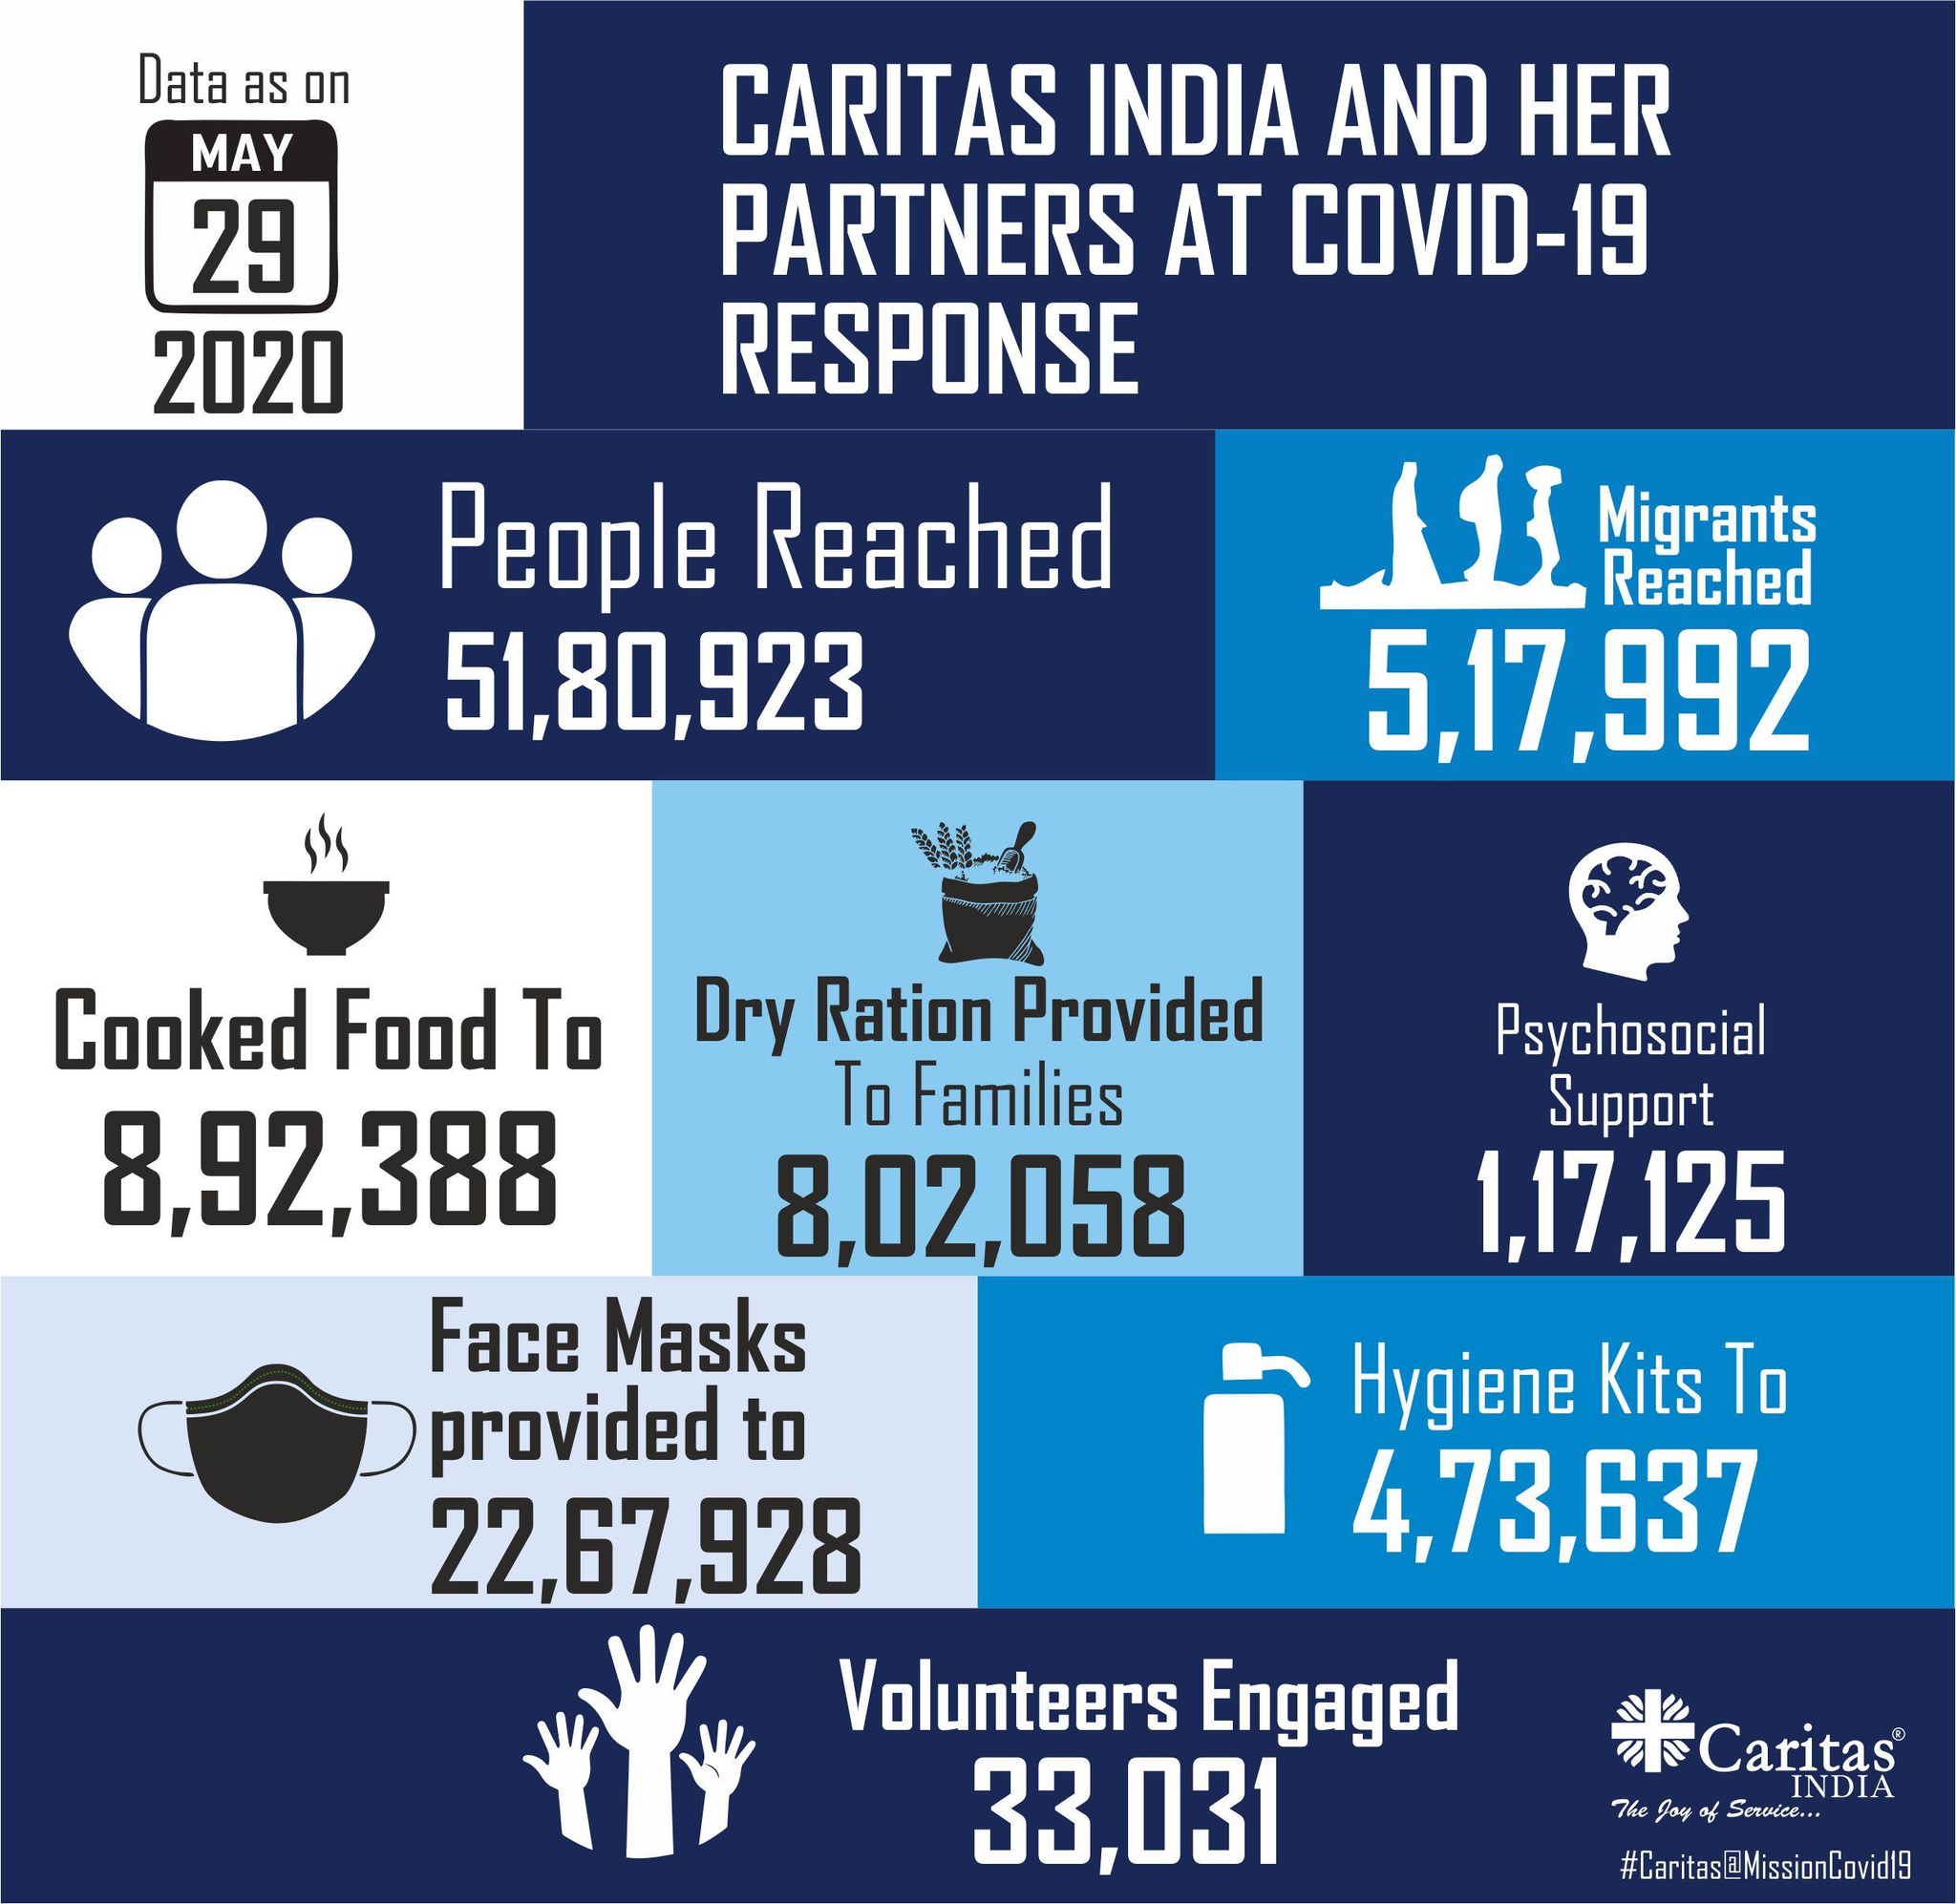Draw attention to some important aspects in this diagram. As of May 29, 2020, a total of 1,17,125 individuals in India received psychosocial support. As of May 29, 2020, it is estimated that 5,17,992 migrants have reached India. As of May 29, 2020, a total of 8,02,058 families in India were provided with dry rations. 